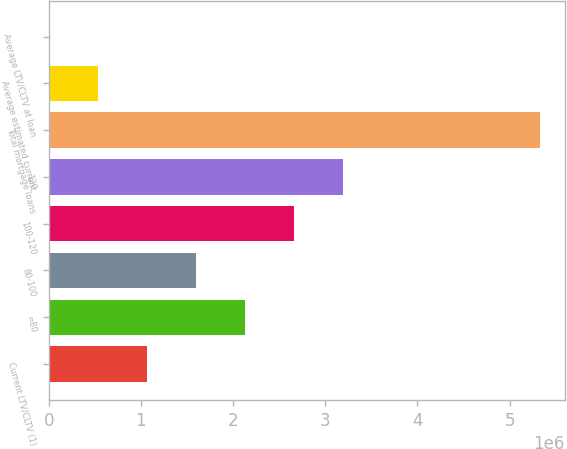Convert chart to OTSL. <chart><loc_0><loc_0><loc_500><loc_500><bar_chart><fcel>Current LTV/CLTV (1)<fcel>=80<fcel>80-100<fcel>100-120<fcel>120<fcel>Total mortgage loans<fcel>Average estimated current<fcel>Average LTV/CLTV at loan<nl><fcel>1.06579e+06<fcel>2.13151e+06<fcel>1.59865e+06<fcel>2.66437e+06<fcel>3.19723e+06<fcel>5.32866e+06<fcel>532937<fcel>79.2<nl></chart> 